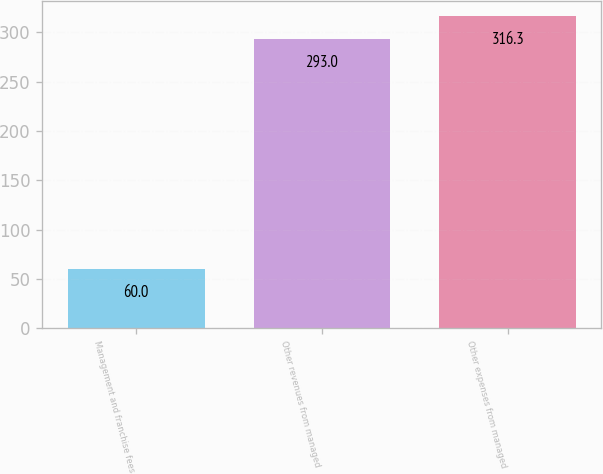Convert chart to OTSL. <chart><loc_0><loc_0><loc_500><loc_500><bar_chart><fcel>Management and franchise fees<fcel>Other revenues from managed<fcel>Other expenses from managed<nl><fcel>60<fcel>293<fcel>316.3<nl></chart> 